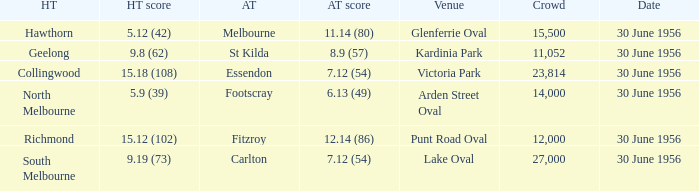What is the home team for punt road oval? Richmond. 